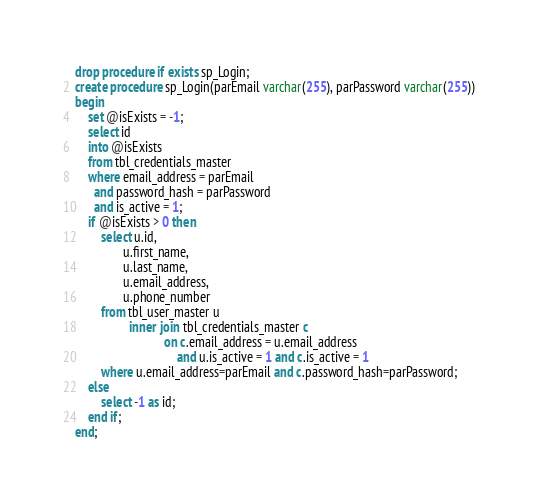Convert code to text. <code><loc_0><loc_0><loc_500><loc_500><_SQL_>drop procedure if exists sp_Login;
create procedure sp_Login(parEmail varchar(255), parPassword varchar(255))
begin
    set @isExists = -1;
    select id
    into @isExists
    from tbl_credentials_master
    where email_address = parEmail
      and password_hash = parPassword
      and is_active = 1;
    if @isExists > 0 then
        select u.id,
               u.first_name,
               u.last_name,
               u.email_address,
               u.phone_number
        from tbl_user_master u
                 inner join tbl_credentials_master c
                            on c.email_address = u.email_address
                                and u.is_active = 1 and c.is_active = 1
        where u.email_address=parEmail and c.password_hash=parPassword;
    else
        select -1 as id;
    end if;
end;</code> 